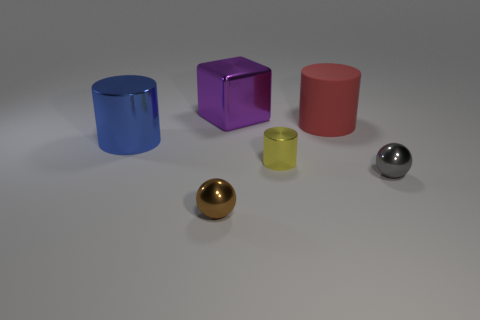Subtract all small shiny cylinders. How many cylinders are left? 2 Subtract 1 balls. How many balls are left? 1 Add 2 big purple metal blocks. How many objects exist? 8 Subtract all gray cubes. How many blue cylinders are left? 1 Add 4 large rubber cylinders. How many large rubber cylinders are left? 5 Add 4 tiny metallic cylinders. How many tiny metallic cylinders exist? 5 Subtract all red cylinders. How many cylinders are left? 2 Subtract 0 purple cylinders. How many objects are left? 6 Subtract all spheres. How many objects are left? 4 Subtract all yellow blocks. Subtract all purple cylinders. How many blocks are left? 1 